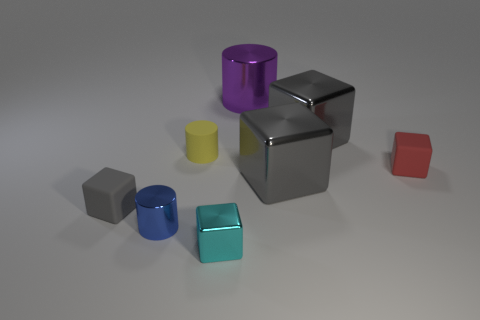How many cyan shiny blocks are the same size as the yellow cylinder? 1 